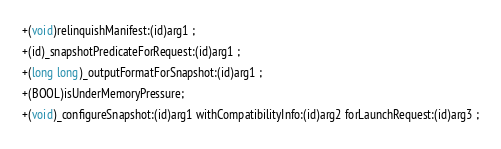Convert code to text. <code><loc_0><loc_0><loc_500><loc_500><_C_>+(void)relinquishManifest:(id)arg1 ;
+(id)_snapshotPredicateForRequest:(id)arg1 ;
+(long long)_outputFormatForSnapshot:(id)arg1 ;
+(BOOL)isUnderMemoryPressure;
+(void)_configureSnapshot:(id)arg1 withCompatibilityInfo:(id)arg2 forLaunchRequest:(id)arg3 ;</code> 